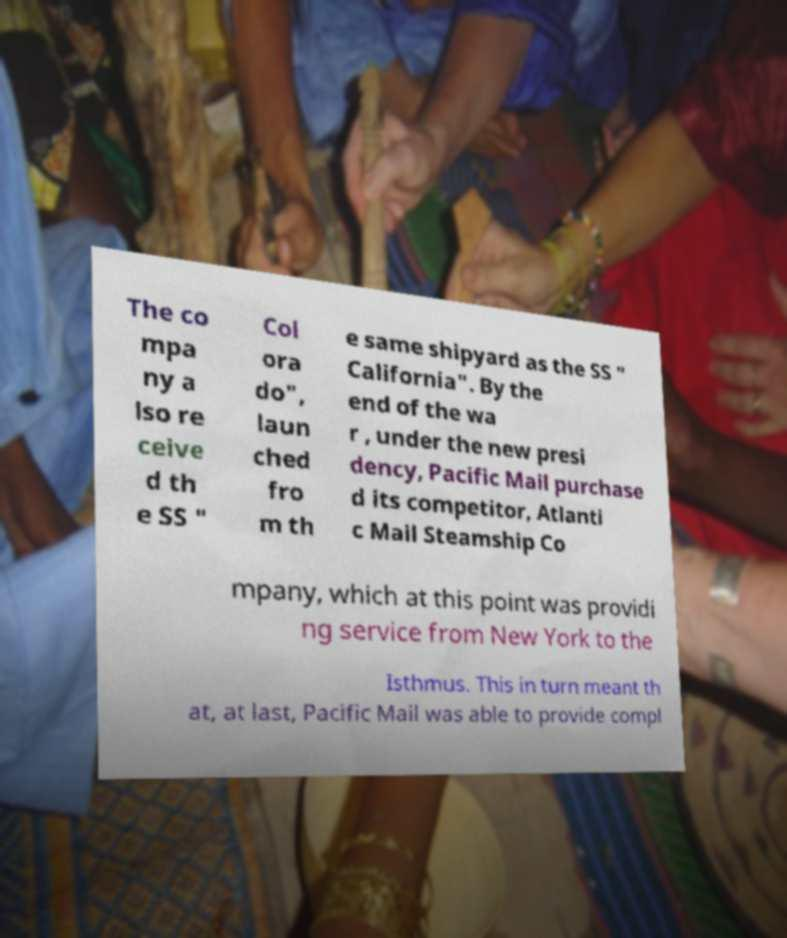Can you read and provide the text displayed in the image?This photo seems to have some interesting text. Can you extract and type it out for me? The co mpa ny a lso re ceive d th e SS " Col ora do", laun ched fro m th e same shipyard as the SS " California". By the end of the wa r , under the new presi dency, Pacific Mail purchase d its competitor, Atlanti c Mail Steamship Co mpany, which at this point was providi ng service from New York to the Isthmus. This in turn meant th at, at last, Pacific Mail was able to provide compl 